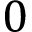<formula> <loc_0><loc_0><loc_500><loc_500>0</formula> 